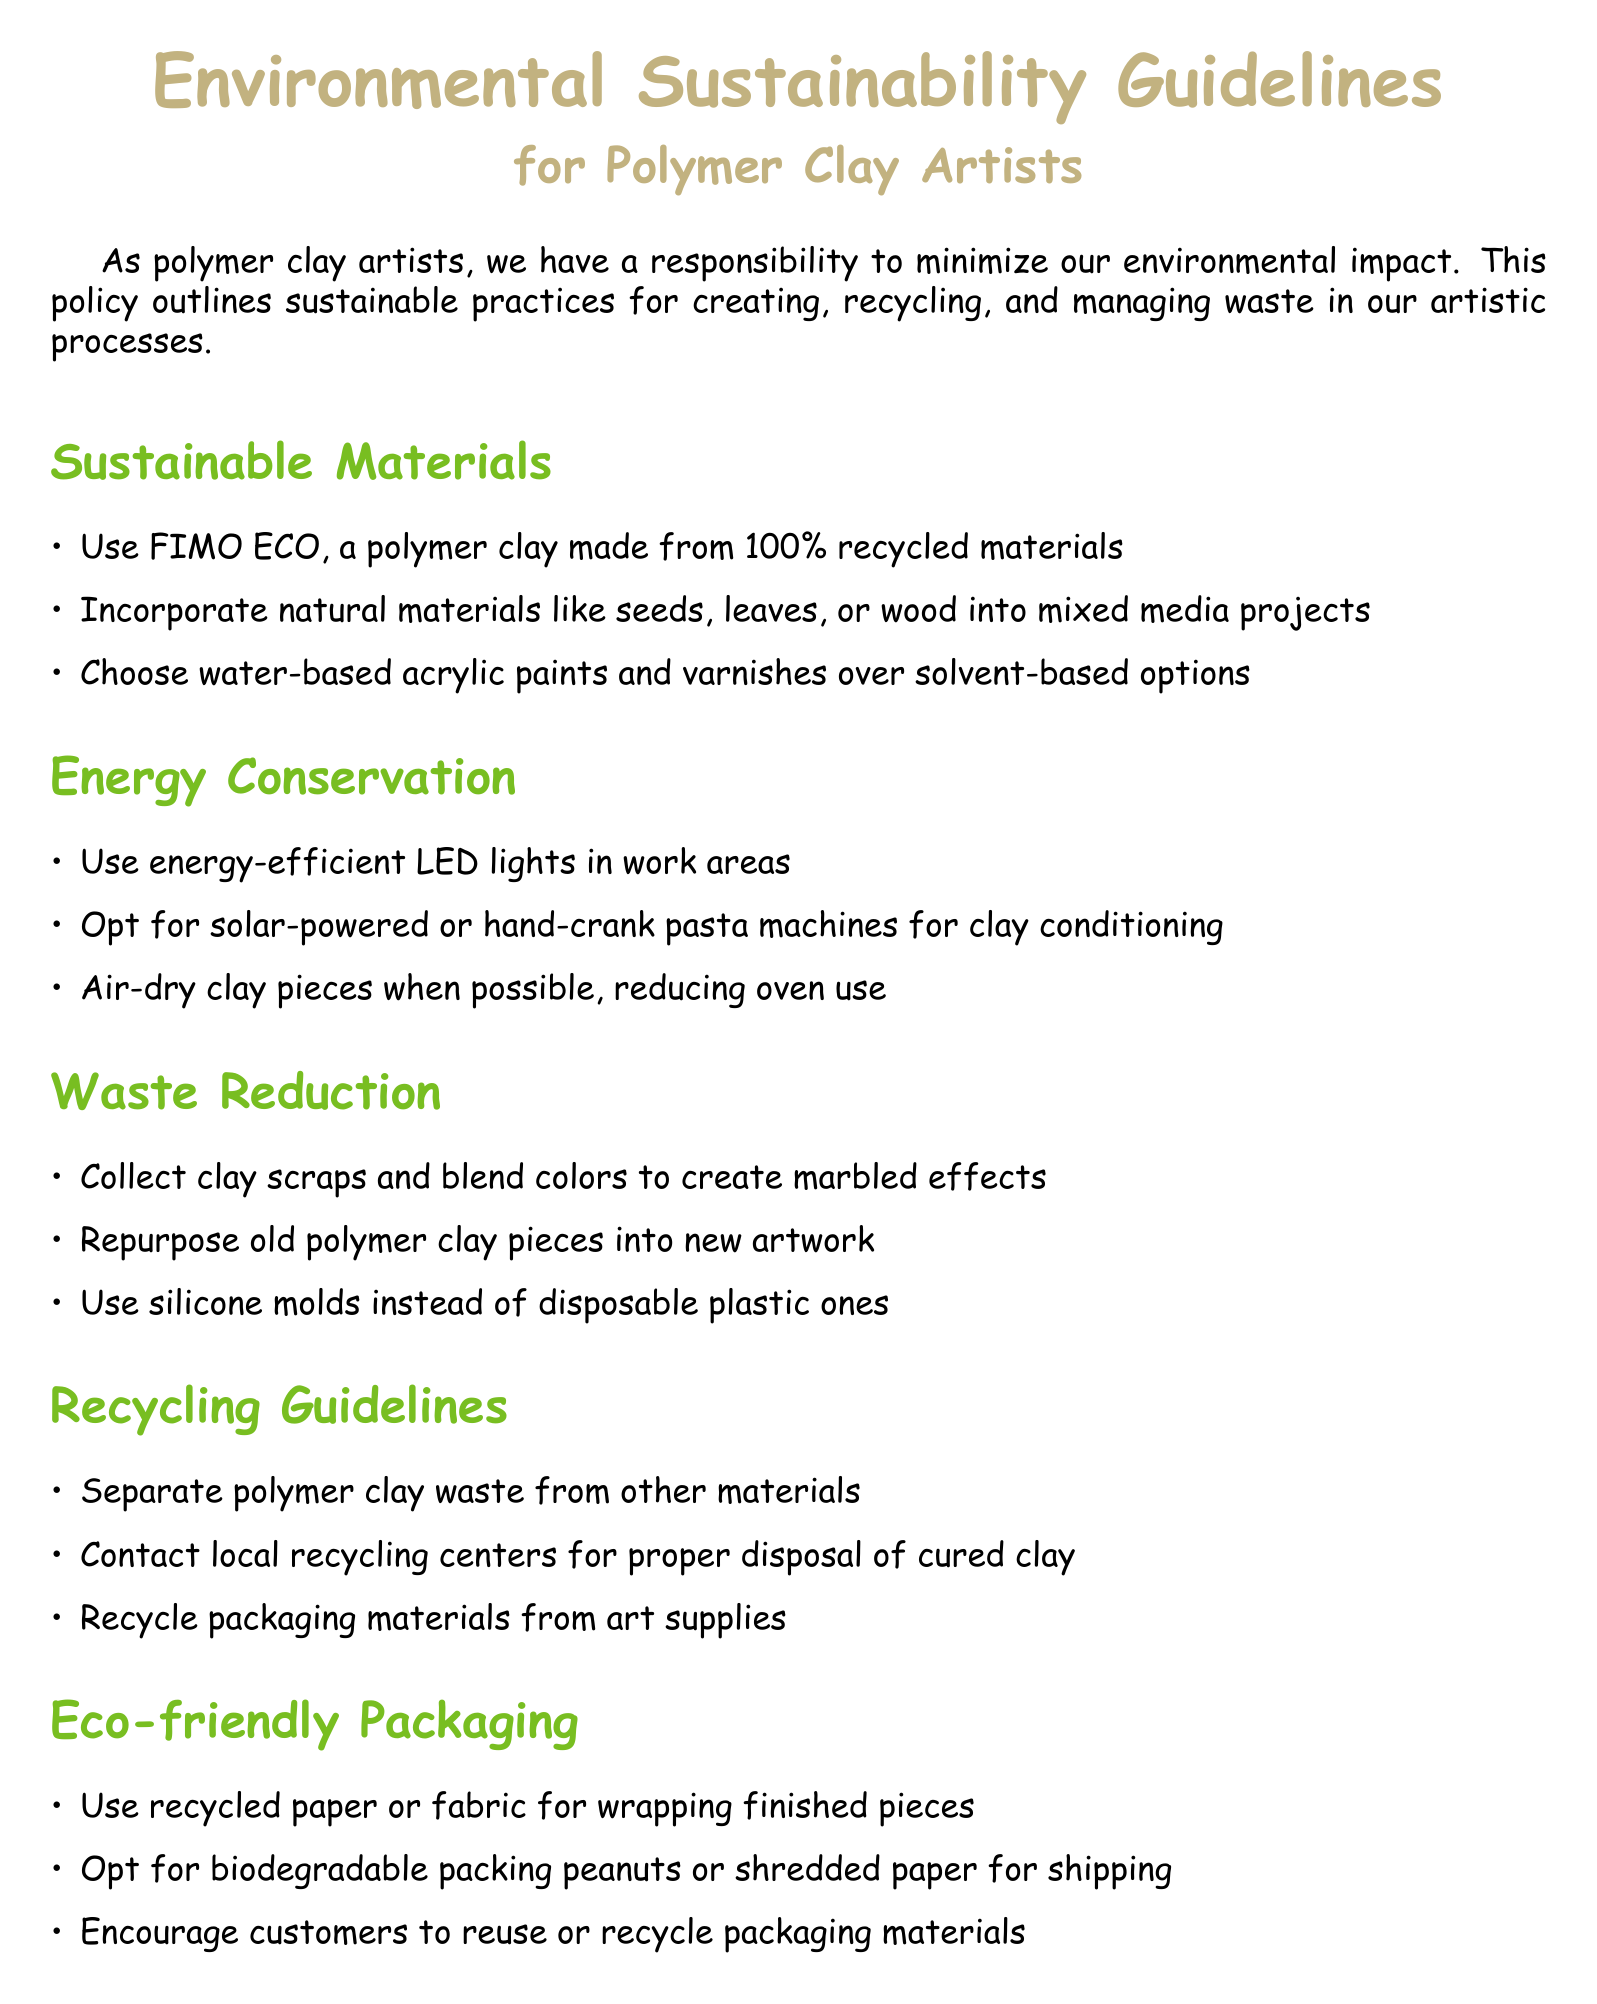What is the title of the document? The title of the document is the first large text presented in the center of the page, which outlines the subject matter for polymer clay artists.
Answer: Environmental Sustainability Guidelines What material is recommended for sustainable art making? The document explicitly mentions FIMO ECO as an environmentally friendly option made from recycled materials.
Answer: FIMO ECO What type of lighting is suggested for energy conservation? The document advises using energy-efficient lighting options in work areas to optimize energy usage.
Answer: LED lights What should be done with polymer clay waste? According to the recycling guidelines, clay waste should be handled in a specific way to ensure proper disposal and recycling.
Answer: Separate Name one eco-friendly packaging option listed in the document. The document includes various alternatives for packaging, one of which is using recycled materials for finishing touches.
Answer: Recycled paper What is one way to reduce waste mentioned in the document? The document includes several strategies for waste reduction, emphasizing the importance of creatively using materials.
Answer: Repurpose old polymer clay pieces How can artists engage with the community according to the policy? The document encourages collaboration with other entities to promote sustainable practices and share knowledge within the artistic community.
Answer: Organize workshops What should be done with cured polymer clay? Proper disposal is highlighted in the guidelines to ensure no environmental harm comes from the waste produced after curing polymer clay.
Answer: Contact local recycling centers 